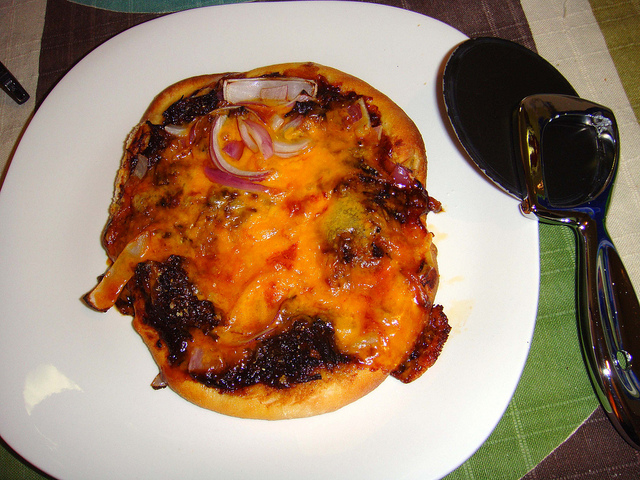<image>What kind of meat is this? I don't know what kind of meat this is. It can be hamburger, beef, or chicken. What kind of meat is this? I am not sure what kind of meat it is. It can be hamburger, beef, or chicken. 